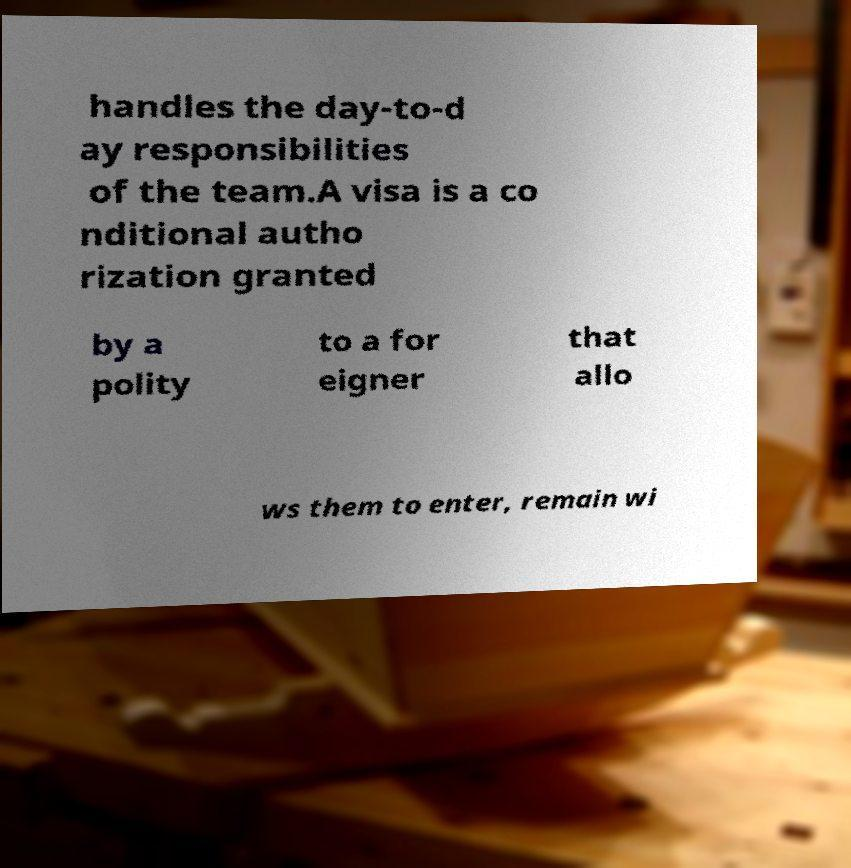What messages or text are displayed in this image? I need them in a readable, typed format. handles the day-to-d ay responsibilities of the team.A visa is a co nditional autho rization granted by a polity to a for eigner that allo ws them to enter, remain wi 